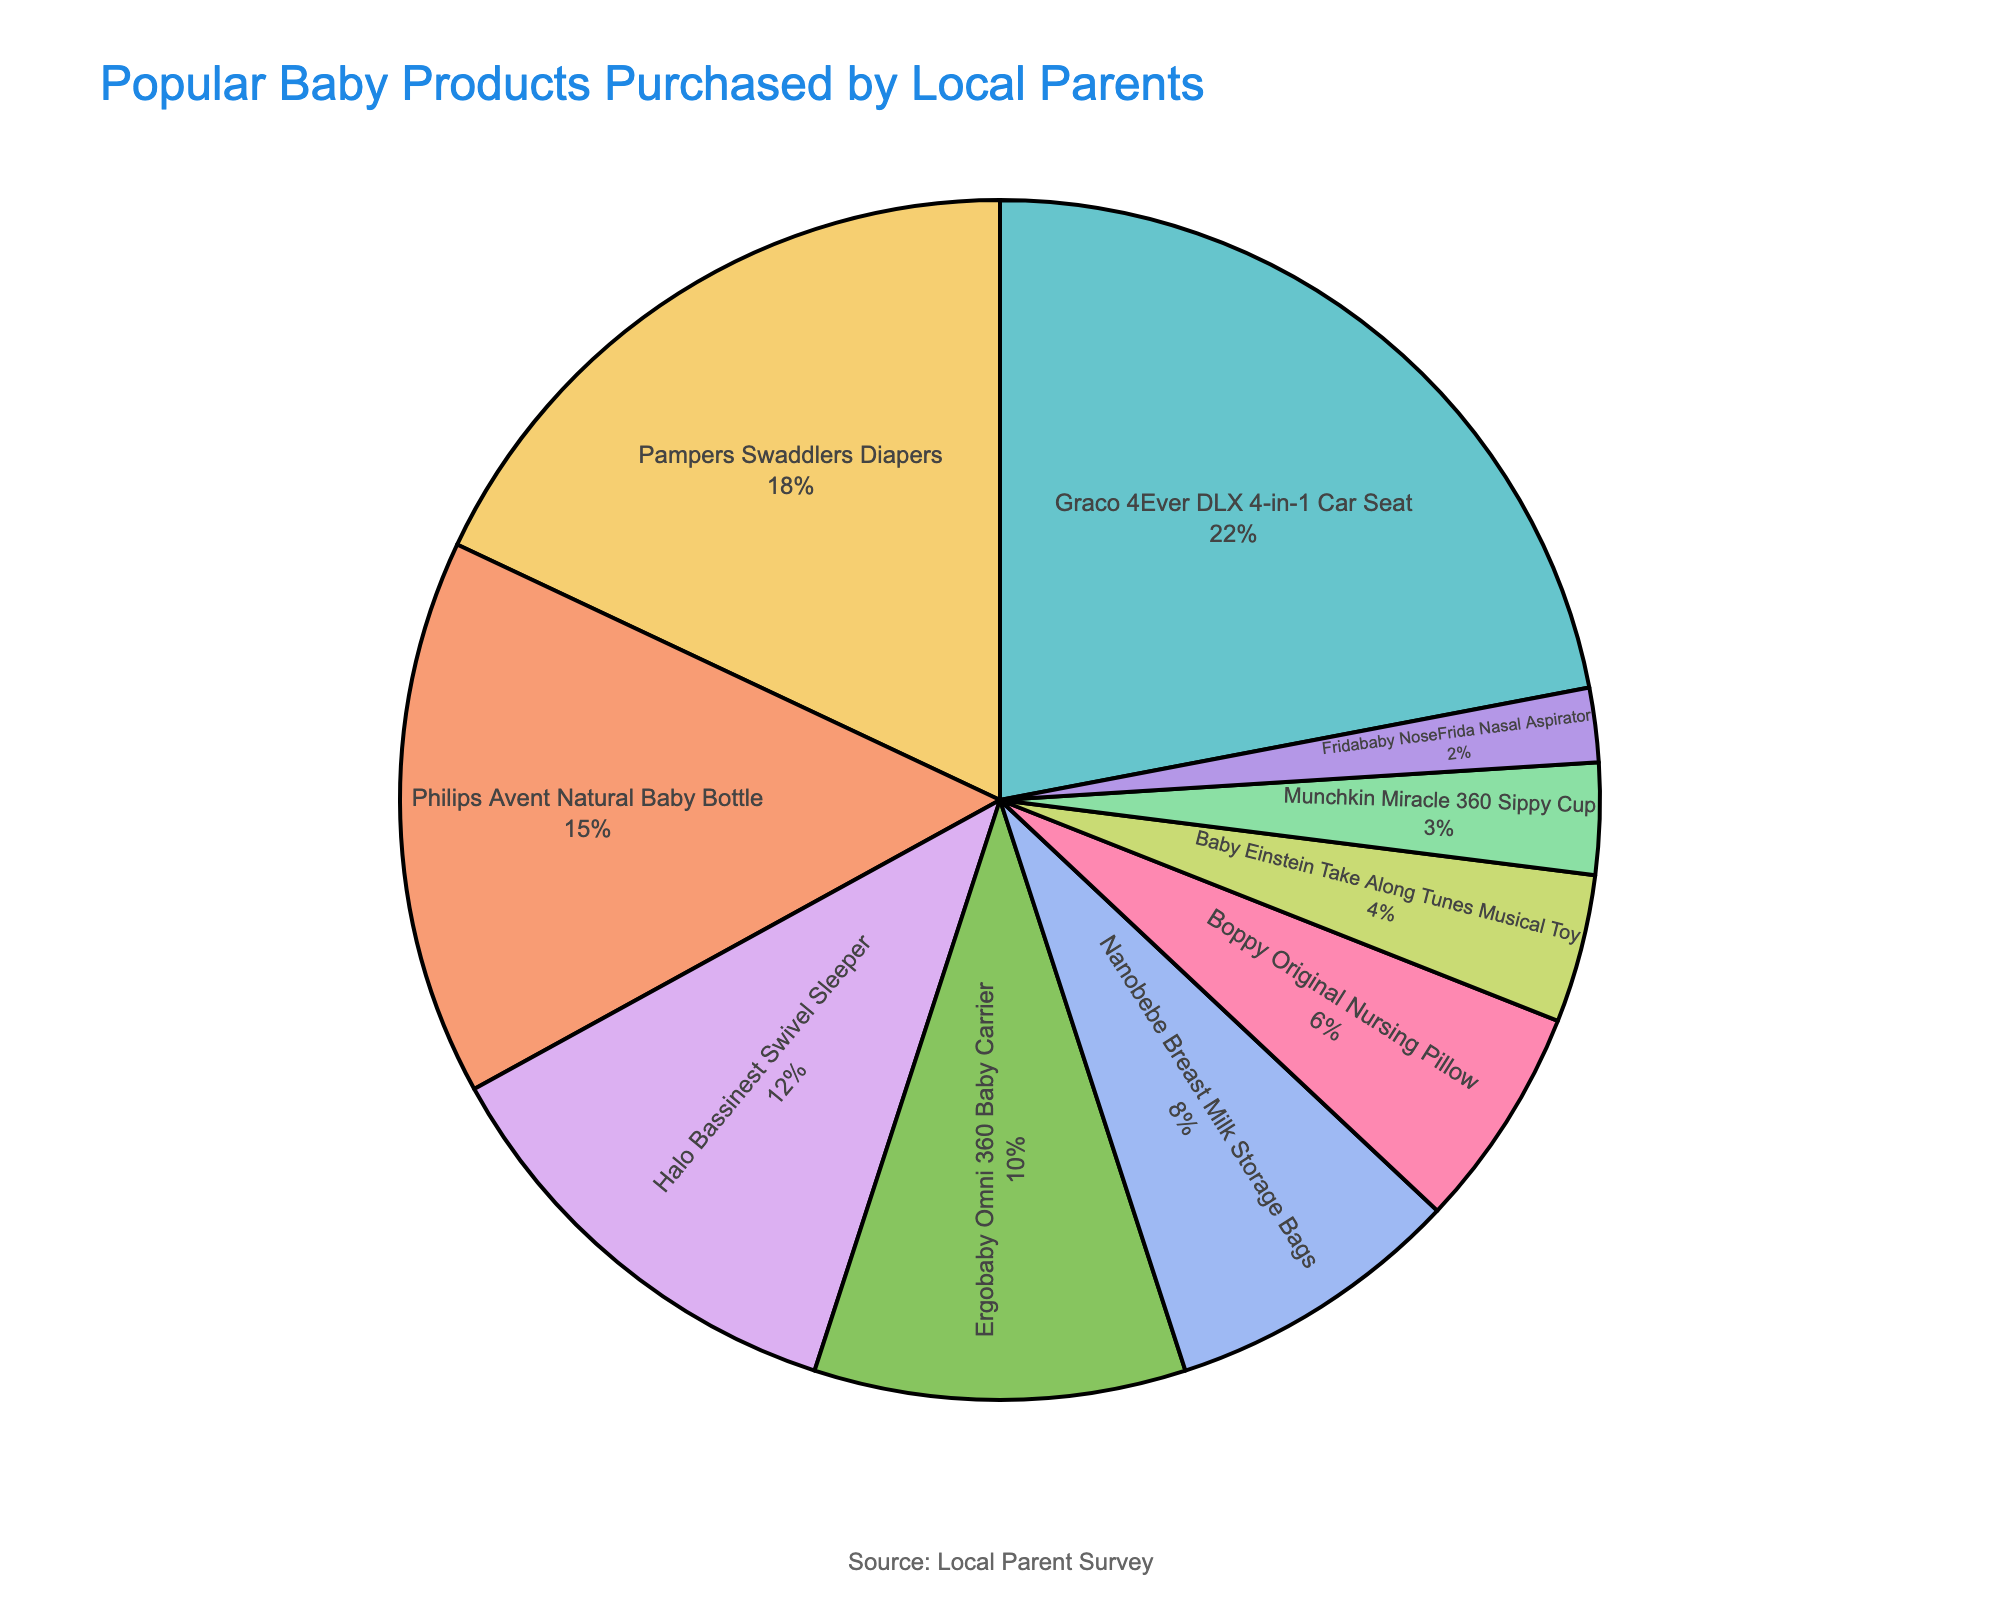What's the most popular baby product purchased by local parents? Look at the segment representing the highest percentage. The Graco 4Ever DLX 4-in-1 Car Seat has the largest segment at 22%.
Answer: Graco 4Ever DLX 4-in-1 Car Seat Which product category contributes least to the total percentage? Identify the smallest segment by percentage. The Fridababy NoseFrida Nasal Aspirator is the smallest with 2%.
Answer: Fridababy NoseFrida Nasal Aspirator How much more popular is the Philips Avent Natural Baby Bottle compared to the Ergobaby Omni 360 Baby Carrier? Subtract the percentage of the Ergobaby Omni 360 Baby Carrier from the Philips Avent Natural Baby Bottle's percentage. 15% - 10% = 5%
Answer: 5% What is the combined percentage of the top three products? Add the percentages of the top three products. 22% (Graco 4Ever DLX 4-in-1 Car Seat) + 18% (Pampers Swaddlers Diapers) + 15% (Philips Avent Natural Baby Bottle) = 55%
Answer: 55% Are the percentages for the Halo Bassinest Swivel Sleeper and Ergobaby Omni 360 Baby Carrier equal? Compare the percentages of these two products. Halo Bassinest Swivel Sleeper is 12%, and Ergobaby Omni 360 Baby Carrier is 10%, which are not equal.
Answer: No How does the sum of the percentages of the bottom four products compare to the Graco 4Ever DLX 4-in-1 Car Seat? Add the percentages of the bottom four products and compare to the top product. Bottom four: 4% + 3% + 2% = 9%. Graco 4Ever DLX 4-in-1 Car Seat is 22%. 9% < 22%.
Answer: Bottom four total is less Which product category is represented by a segment colored in the second position of the chosen color sequence? Look at the colors used and identify the product corresponding to the second color. Assuming pastel colors, the second might be light green, which corresponds to Pampers Swaddlers Diapers at 18%.
Answer: Pampers Swaddlers Diapers What is the difference in popularity between the Halo Bassinest Swivel Sleeper and the Boppy Original Nursing Pillow? Subtract the percentages of these two products. 12% (Halo Bassinest Swivel Sleeper) - 6% (Boppy Original Nursing Pillow) = 6%
Answer: 6% Does the combined percentage of Ergobaby Omni 360 Baby Carrier and Nanobebe Breast Milk Storage Bags exceed the total percentage of Pampers Swaddlers Diapers? Add the percentages of Ergobaby Omni 360 Baby Carrier and Nanobebe Breast Milk Storage Bags and compare with Pampers Swaddlers Diapers. 10% + 8% = 18%, which is equal to Pampers Swaddlers Diapers.
Answer: No, they are equal What's the exact percentage contributed by the Graco 4Ever DLX 4-in-1 Car Seat and Pampers Swaddlers Diapers combined? Add the percentages of both products. 22% (Graco 4Ever DLX 4-in-1 Car Seat) + 18% (Pampers Swaddlers Diapers) = 40%
Answer: 40% 